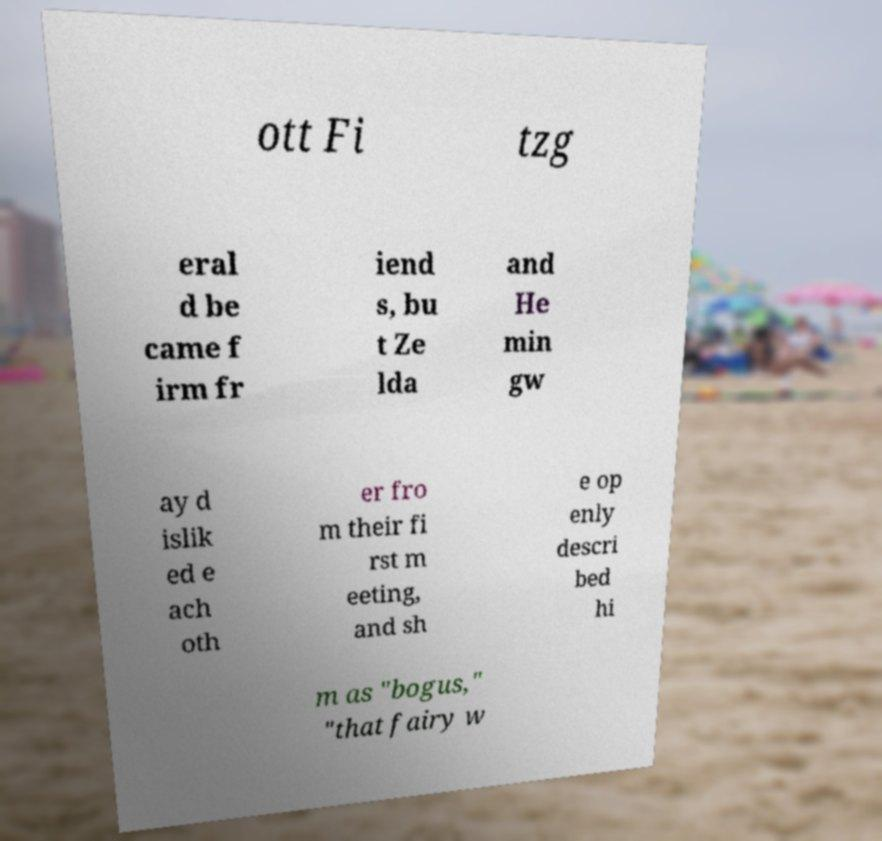What messages or text are displayed in this image? I need them in a readable, typed format. ott Fi tzg eral d be came f irm fr iend s, bu t Ze lda and He min gw ay d islik ed e ach oth er fro m their fi rst m eeting, and sh e op enly descri bed hi m as "bogus," "that fairy w 